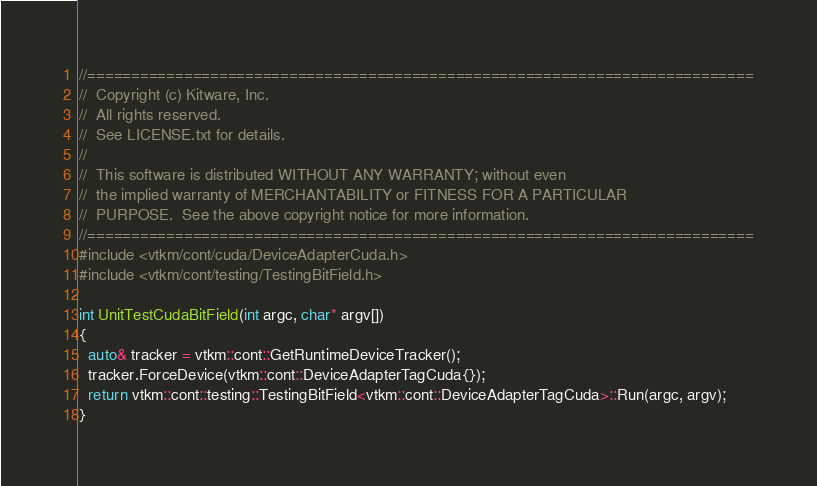Convert code to text. <code><loc_0><loc_0><loc_500><loc_500><_Cuda_>//============================================================================
//  Copyright (c) Kitware, Inc.
//  All rights reserved.
//  See LICENSE.txt for details.
//
//  This software is distributed WITHOUT ANY WARRANTY; without even
//  the implied warranty of MERCHANTABILITY or FITNESS FOR A PARTICULAR
//  PURPOSE.  See the above copyright notice for more information.
//============================================================================
#include <vtkm/cont/cuda/DeviceAdapterCuda.h>
#include <vtkm/cont/testing/TestingBitField.h>

int UnitTestCudaBitField(int argc, char* argv[])
{
  auto& tracker = vtkm::cont::GetRuntimeDeviceTracker();
  tracker.ForceDevice(vtkm::cont::DeviceAdapterTagCuda{});
  return vtkm::cont::testing::TestingBitField<vtkm::cont::DeviceAdapterTagCuda>::Run(argc, argv);
}
</code> 